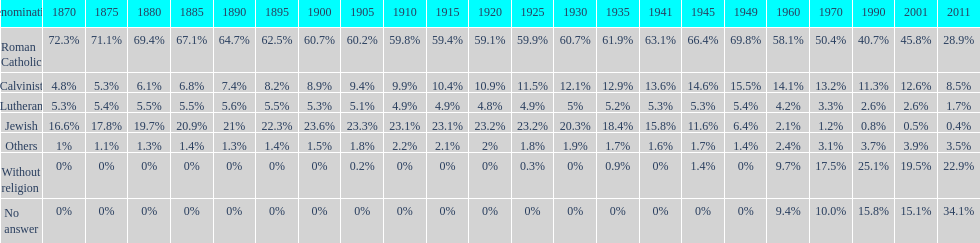What is the largest religious denomination in budapest? Roman Catholic. 